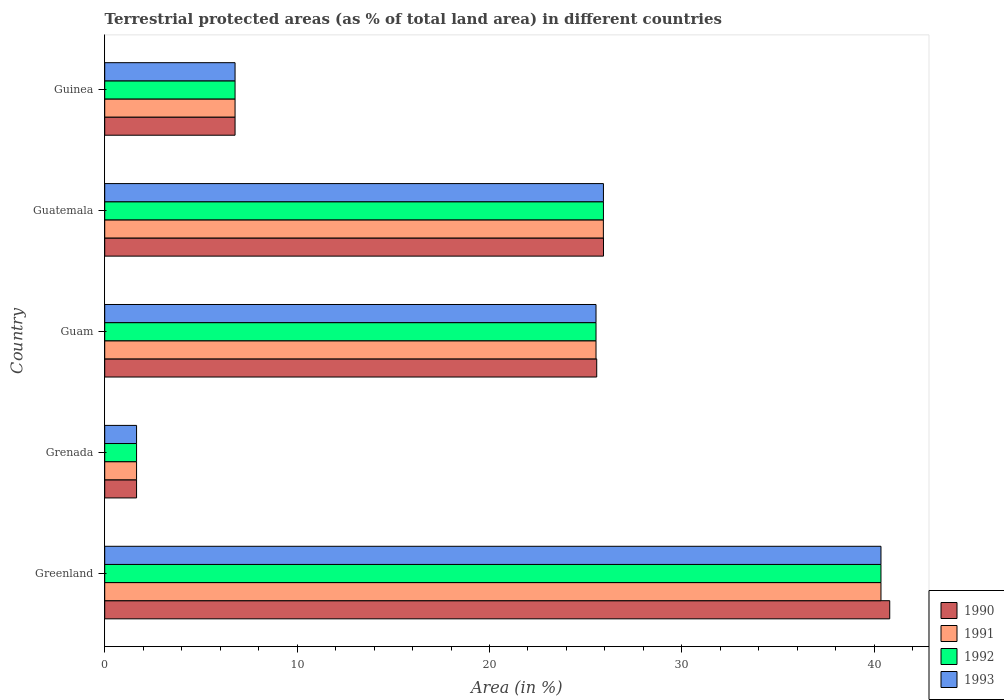How many different coloured bars are there?
Offer a very short reply. 4. How many groups of bars are there?
Provide a short and direct response. 5. Are the number of bars on each tick of the Y-axis equal?
Provide a short and direct response. Yes. How many bars are there on the 4th tick from the bottom?
Provide a short and direct response. 4. What is the label of the 4th group of bars from the top?
Give a very brief answer. Grenada. In how many cases, is the number of bars for a given country not equal to the number of legend labels?
Keep it short and to the point. 0. What is the percentage of terrestrial protected land in 1990 in Greenland?
Your answer should be compact. 40.81. Across all countries, what is the maximum percentage of terrestrial protected land in 1993?
Make the answer very short. 40.35. Across all countries, what is the minimum percentage of terrestrial protected land in 1990?
Your response must be concise. 1.66. In which country was the percentage of terrestrial protected land in 1991 maximum?
Your answer should be compact. Greenland. In which country was the percentage of terrestrial protected land in 1993 minimum?
Provide a short and direct response. Grenada. What is the total percentage of terrestrial protected land in 1990 in the graph?
Your response must be concise. 100.74. What is the difference between the percentage of terrestrial protected land in 1993 in Greenland and that in Guam?
Your response must be concise. 14.81. What is the difference between the percentage of terrestrial protected land in 1990 in Greenland and the percentage of terrestrial protected land in 1991 in Guinea?
Ensure brevity in your answer.  34.03. What is the average percentage of terrestrial protected land in 1993 per country?
Keep it short and to the point. 20.05. What is the difference between the percentage of terrestrial protected land in 1991 and percentage of terrestrial protected land in 1992 in Guam?
Your response must be concise. 0. In how many countries, is the percentage of terrestrial protected land in 1990 greater than 10 %?
Your answer should be very brief. 3. What is the ratio of the percentage of terrestrial protected land in 1992 in Greenland to that in Grenada?
Keep it short and to the point. 24.38. Is the percentage of terrestrial protected land in 1991 in Greenland less than that in Guam?
Make the answer very short. No. Is the difference between the percentage of terrestrial protected land in 1991 in Grenada and Guam greater than the difference between the percentage of terrestrial protected land in 1992 in Grenada and Guam?
Offer a very short reply. No. What is the difference between the highest and the second highest percentage of terrestrial protected land in 1991?
Provide a succinct answer. 14.43. What is the difference between the highest and the lowest percentage of terrestrial protected land in 1991?
Offer a very short reply. 38.69. In how many countries, is the percentage of terrestrial protected land in 1993 greater than the average percentage of terrestrial protected land in 1993 taken over all countries?
Your answer should be very brief. 3. Is it the case that in every country, the sum of the percentage of terrestrial protected land in 1992 and percentage of terrestrial protected land in 1990 is greater than the sum of percentage of terrestrial protected land in 1991 and percentage of terrestrial protected land in 1993?
Give a very brief answer. No. What does the 3rd bar from the top in Guam represents?
Offer a very short reply. 1991. What does the 3rd bar from the bottom in Grenada represents?
Provide a short and direct response. 1992. Are the values on the major ticks of X-axis written in scientific E-notation?
Make the answer very short. No. Does the graph contain any zero values?
Your answer should be compact. No. Does the graph contain grids?
Offer a terse response. No. How are the legend labels stacked?
Your answer should be very brief. Vertical. What is the title of the graph?
Offer a terse response. Terrestrial protected areas (as % of total land area) in different countries. Does "1986" appear as one of the legend labels in the graph?
Ensure brevity in your answer.  No. What is the label or title of the X-axis?
Make the answer very short. Area (in %). What is the Area (in %) of 1990 in Greenland?
Your answer should be compact. 40.81. What is the Area (in %) of 1991 in Greenland?
Make the answer very short. 40.35. What is the Area (in %) of 1992 in Greenland?
Your answer should be very brief. 40.35. What is the Area (in %) in 1993 in Greenland?
Offer a very short reply. 40.35. What is the Area (in %) of 1990 in Grenada?
Keep it short and to the point. 1.66. What is the Area (in %) in 1991 in Grenada?
Make the answer very short. 1.66. What is the Area (in %) of 1992 in Grenada?
Your answer should be very brief. 1.66. What is the Area (in %) of 1993 in Grenada?
Provide a short and direct response. 1.66. What is the Area (in %) in 1990 in Guam?
Make the answer very short. 25.57. What is the Area (in %) of 1991 in Guam?
Your answer should be compact. 25.54. What is the Area (in %) of 1992 in Guam?
Offer a very short reply. 25.54. What is the Area (in %) in 1993 in Guam?
Keep it short and to the point. 25.54. What is the Area (in %) of 1990 in Guatemala?
Ensure brevity in your answer.  25.93. What is the Area (in %) of 1991 in Guatemala?
Keep it short and to the point. 25.92. What is the Area (in %) in 1992 in Guatemala?
Your response must be concise. 25.92. What is the Area (in %) in 1993 in Guatemala?
Offer a terse response. 25.92. What is the Area (in %) of 1990 in Guinea?
Make the answer very short. 6.78. What is the Area (in %) of 1991 in Guinea?
Your answer should be compact. 6.78. What is the Area (in %) in 1992 in Guinea?
Your response must be concise. 6.78. What is the Area (in %) of 1993 in Guinea?
Give a very brief answer. 6.78. Across all countries, what is the maximum Area (in %) in 1990?
Your answer should be compact. 40.81. Across all countries, what is the maximum Area (in %) of 1991?
Give a very brief answer. 40.35. Across all countries, what is the maximum Area (in %) in 1992?
Your response must be concise. 40.35. Across all countries, what is the maximum Area (in %) of 1993?
Your answer should be very brief. 40.35. Across all countries, what is the minimum Area (in %) of 1990?
Your answer should be compact. 1.66. Across all countries, what is the minimum Area (in %) of 1991?
Provide a succinct answer. 1.66. Across all countries, what is the minimum Area (in %) of 1992?
Offer a terse response. 1.66. Across all countries, what is the minimum Area (in %) of 1993?
Your answer should be very brief. 1.66. What is the total Area (in %) of 1990 in the graph?
Provide a succinct answer. 100.74. What is the total Area (in %) in 1991 in the graph?
Keep it short and to the point. 100.24. What is the total Area (in %) of 1992 in the graph?
Offer a terse response. 100.24. What is the total Area (in %) in 1993 in the graph?
Offer a terse response. 100.24. What is the difference between the Area (in %) in 1990 in Greenland and that in Grenada?
Your response must be concise. 39.15. What is the difference between the Area (in %) of 1991 in Greenland and that in Grenada?
Your response must be concise. 38.69. What is the difference between the Area (in %) of 1992 in Greenland and that in Grenada?
Give a very brief answer. 38.69. What is the difference between the Area (in %) of 1993 in Greenland and that in Grenada?
Provide a succinct answer. 38.69. What is the difference between the Area (in %) of 1990 in Greenland and that in Guam?
Keep it short and to the point. 15.23. What is the difference between the Area (in %) in 1991 in Greenland and that in Guam?
Ensure brevity in your answer.  14.81. What is the difference between the Area (in %) of 1992 in Greenland and that in Guam?
Your answer should be compact. 14.81. What is the difference between the Area (in %) of 1993 in Greenland and that in Guam?
Your answer should be compact. 14.81. What is the difference between the Area (in %) in 1990 in Greenland and that in Guatemala?
Offer a very short reply. 14.88. What is the difference between the Area (in %) of 1991 in Greenland and that in Guatemala?
Keep it short and to the point. 14.43. What is the difference between the Area (in %) in 1992 in Greenland and that in Guatemala?
Make the answer very short. 14.43. What is the difference between the Area (in %) of 1993 in Greenland and that in Guatemala?
Provide a short and direct response. 14.43. What is the difference between the Area (in %) of 1990 in Greenland and that in Guinea?
Offer a terse response. 34.03. What is the difference between the Area (in %) of 1991 in Greenland and that in Guinea?
Keep it short and to the point. 33.57. What is the difference between the Area (in %) in 1992 in Greenland and that in Guinea?
Offer a very short reply. 33.57. What is the difference between the Area (in %) in 1993 in Greenland and that in Guinea?
Make the answer very short. 33.57. What is the difference between the Area (in %) in 1990 in Grenada and that in Guam?
Make the answer very short. -23.92. What is the difference between the Area (in %) in 1991 in Grenada and that in Guam?
Provide a succinct answer. -23.88. What is the difference between the Area (in %) in 1992 in Grenada and that in Guam?
Keep it short and to the point. -23.88. What is the difference between the Area (in %) in 1993 in Grenada and that in Guam?
Your answer should be very brief. -23.88. What is the difference between the Area (in %) of 1990 in Grenada and that in Guatemala?
Offer a very short reply. -24.27. What is the difference between the Area (in %) of 1991 in Grenada and that in Guatemala?
Provide a succinct answer. -24.27. What is the difference between the Area (in %) of 1992 in Grenada and that in Guatemala?
Your response must be concise. -24.27. What is the difference between the Area (in %) of 1993 in Grenada and that in Guatemala?
Make the answer very short. -24.27. What is the difference between the Area (in %) in 1990 in Grenada and that in Guinea?
Your response must be concise. -5.12. What is the difference between the Area (in %) in 1991 in Grenada and that in Guinea?
Provide a short and direct response. -5.12. What is the difference between the Area (in %) of 1992 in Grenada and that in Guinea?
Your answer should be compact. -5.12. What is the difference between the Area (in %) of 1993 in Grenada and that in Guinea?
Keep it short and to the point. -5.12. What is the difference between the Area (in %) in 1990 in Guam and that in Guatemala?
Provide a short and direct response. -0.35. What is the difference between the Area (in %) of 1991 in Guam and that in Guatemala?
Offer a terse response. -0.38. What is the difference between the Area (in %) of 1992 in Guam and that in Guatemala?
Your answer should be compact. -0.39. What is the difference between the Area (in %) in 1993 in Guam and that in Guatemala?
Give a very brief answer. -0.39. What is the difference between the Area (in %) in 1990 in Guam and that in Guinea?
Give a very brief answer. 18.8. What is the difference between the Area (in %) in 1991 in Guam and that in Guinea?
Offer a very short reply. 18.76. What is the difference between the Area (in %) in 1992 in Guam and that in Guinea?
Provide a succinct answer. 18.76. What is the difference between the Area (in %) in 1993 in Guam and that in Guinea?
Your answer should be very brief. 18.76. What is the difference between the Area (in %) in 1990 in Guatemala and that in Guinea?
Give a very brief answer. 19.15. What is the difference between the Area (in %) of 1991 in Guatemala and that in Guinea?
Your answer should be very brief. 19.15. What is the difference between the Area (in %) in 1992 in Guatemala and that in Guinea?
Give a very brief answer. 19.15. What is the difference between the Area (in %) of 1993 in Guatemala and that in Guinea?
Give a very brief answer. 19.15. What is the difference between the Area (in %) of 1990 in Greenland and the Area (in %) of 1991 in Grenada?
Provide a short and direct response. 39.15. What is the difference between the Area (in %) of 1990 in Greenland and the Area (in %) of 1992 in Grenada?
Your answer should be very brief. 39.15. What is the difference between the Area (in %) of 1990 in Greenland and the Area (in %) of 1993 in Grenada?
Your answer should be very brief. 39.15. What is the difference between the Area (in %) of 1991 in Greenland and the Area (in %) of 1992 in Grenada?
Provide a succinct answer. 38.69. What is the difference between the Area (in %) of 1991 in Greenland and the Area (in %) of 1993 in Grenada?
Provide a succinct answer. 38.69. What is the difference between the Area (in %) of 1992 in Greenland and the Area (in %) of 1993 in Grenada?
Your answer should be very brief. 38.69. What is the difference between the Area (in %) in 1990 in Greenland and the Area (in %) in 1991 in Guam?
Ensure brevity in your answer.  15.27. What is the difference between the Area (in %) in 1990 in Greenland and the Area (in %) in 1992 in Guam?
Your answer should be very brief. 15.27. What is the difference between the Area (in %) in 1990 in Greenland and the Area (in %) in 1993 in Guam?
Give a very brief answer. 15.27. What is the difference between the Area (in %) in 1991 in Greenland and the Area (in %) in 1992 in Guam?
Make the answer very short. 14.81. What is the difference between the Area (in %) of 1991 in Greenland and the Area (in %) of 1993 in Guam?
Offer a very short reply. 14.81. What is the difference between the Area (in %) in 1992 in Greenland and the Area (in %) in 1993 in Guam?
Make the answer very short. 14.81. What is the difference between the Area (in %) in 1990 in Greenland and the Area (in %) in 1991 in Guatemala?
Ensure brevity in your answer.  14.89. What is the difference between the Area (in %) of 1990 in Greenland and the Area (in %) of 1992 in Guatemala?
Your response must be concise. 14.88. What is the difference between the Area (in %) in 1990 in Greenland and the Area (in %) in 1993 in Guatemala?
Provide a succinct answer. 14.88. What is the difference between the Area (in %) of 1991 in Greenland and the Area (in %) of 1992 in Guatemala?
Your response must be concise. 14.43. What is the difference between the Area (in %) in 1991 in Greenland and the Area (in %) in 1993 in Guatemala?
Make the answer very short. 14.43. What is the difference between the Area (in %) of 1992 in Greenland and the Area (in %) of 1993 in Guatemala?
Keep it short and to the point. 14.43. What is the difference between the Area (in %) in 1990 in Greenland and the Area (in %) in 1991 in Guinea?
Your answer should be very brief. 34.03. What is the difference between the Area (in %) in 1990 in Greenland and the Area (in %) in 1992 in Guinea?
Offer a terse response. 34.03. What is the difference between the Area (in %) in 1990 in Greenland and the Area (in %) in 1993 in Guinea?
Keep it short and to the point. 34.03. What is the difference between the Area (in %) of 1991 in Greenland and the Area (in %) of 1992 in Guinea?
Your answer should be very brief. 33.57. What is the difference between the Area (in %) in 1991 in Greenland and the Area (in %) in 1993 in Guinea?
Your answer should be compact. 33.57. What is the difference between the Area (in %) in 1992 in Greenland and the Area (in %) in 1993 in Guinea?
Provide a short and direct response. 33.57. What is the difference between the Area (in %) of 1990 in Grenada and the Area (in %) of 1991 in Guam?
Offer a very short reply. -23.88. What is the difference between the Area (in %) in 1990 in Grenada and the Area (in %) in 1992 in Guam?
Your answer should be very brief. -23.88. What is the difference between the Area (in %) of 1990 in Grenada and the Area (in %) of 1993 in Guam?
Ensure brevity in your answer.  -23.88. What is the difference between the Area (in %) in 1991 in Grenada and the Area (in %) in 1992 in Guam?
Offer a very short reply. -23.88. What is the difference between the Area (in %) of 1991 in Grenada and the Area (in %) of 1993 in Guam?
Provide a short and direct response. -23.88. What is the difference between the Area (in %) of 1992 in Grenada and the Area (in %) of 1993 in Guam?
Your response must be concise. -23.88. What is the difference between the Area (in %) of 1990 in Grenada and the Area (in %) of 1991 in Guatemala?
Your answer should be compact. -24.27. What is the difference between the Area (in %) in 1990 in Grenada and the Area (in %) in 1992 in Guatemala?
Your answer should be very brief. -24.27. What is the difference between the Area (in %) in 1990 in Grenada and the Area (in %) in 1993 in Guatemala?
Provide a short and direct response. -24.27. What is the difference between the Area (in %) of 1991 in Grenada and the Area (in %) of 1992 in Guatemala?
Provide a short and direct response. -24.27. What is the difference between the Area (in %) of 1991 in Grenada and the Area (in %) of 1993 in Guatemala?
Ensure brevity in your answer.  -24.27. What is the difference between the Area (in %) of 1992 in Grenada and the Area (in %) of 1993 in Guatemala?
Your answer should be compact. -24.27. What is the difference between the Area (in %) in 1990 in Grenada and the Area (in %) in 1991 in Guinea?
Make the answer very short. -5.12. What is the difference between the Area (in %) of 1990 in Grenada and the Area (in %) of 1992 in Guinea?
Offer a very short reply. -5.12. What is the difference between the Area (in %) in 1990 in Grenada and the Area (in %) in 1993 in Guinea?
Provide a succinct answer. -5.12. What is the difference between the Area (in %) of 1991 in Grenada and the Area (in %) of 1992 in Guinea?
Ensure brevity in your answer.  -5.12. What is the difference between the Area (in %) of 1991 in Grenada and the Area (in %) of 1993 in Guinea?
Your answer should be compact. -5.12. What is the difference between the Area (in %) of 1992 in Grenada and the Area (in %) of 1993 in Guinea?
Make the answer very short. -5.12. What is the difference between the Area (in %) in 1990 in Guam and the Area (in %) in 1991 in Guatemala?
Provide a short and direct response. -0.35. What is the difference between the Area (in %) in 1990 in Guam and the Area (in %) in 1992 in Guatemala?
Offer a very short reply. -0.35. What is the difference between the Area (in %) of 1990 in Guam and the Area (in %) of 1993 in Guatemala?
Ensure brevity in your answer.  -0.35. What is the difference between the Area (in %) of 1991 in Guam and the Area (in %) of 1992 in Guatemala?
Offer a terse response. -0.39. What is the difference between the Area (in %) of 1991 in Guam and the Area (in %) of 1993 in Guatemala?
Offer a very short reply. -0.39. What is the difference between the Area (in %) of 1992 in Guam and the Area (in %) of 1993 in Guatemala?
Offer a very short reply. -0.39. What is the difference between the Area (in %) in 1990 in Guam and the Area (in %) in 1991 in Guinea?
Ensure brevity in your answer.  18.8. What is the difference between the Area (in %) of 1990 in Guam and the Area (in %) of 1992 in Guinea?
Provide a short and direct response. 18.8. What is the difference between the Area (in %) in 1990 in Guam and the Area (in %) in 1993 in Guinea?
Your response must be concise. 18.8. What is the difference between the Area (in %) of 1991 in Guam and the Area (in %) of 1992 in Guinea?
Make the answer very short. 18.76. What is the difference between the Area (in %) in 1991 in Guam and the Area (in %) in 1993 in Guinea?
Give a very brief answer. 18.76. What is the difference between the Area (in %) in 1992 in Guam and the Area (in %) in 1993 in Guinea?
Offer a terse response. 18.76. What is the difference between the Area (in %) of 1990 in Guatemala and the Area (in %) of 1991 in Guinea?
Your answer should be very brief. 19.15. What is the difference between the Area (in %) of 1990 in Guatemala and the Area (in %) of 1992 in Guinea?
Offer a very short reply. 19.15. What is the difference between the Area (in %) in 1990 in Guatemala and the Area (in %) in 1993 in Guinea?
Ensure brevity in your answer.  19.15. What is the difference between the Area (in %) in 1991 in Guatemala and the Area (in %) in 1992 in Guinea?
Give a very brief answer. 19.15. What is the difference between the Area (in %) of 1991 in Guatemala and the Area (in %) of 1993 in Guinea?
Make the answer very short. 19.15. What is the difference between the Area (in %) of 1992 in Guatemala and the Area (in %) of 1993 in Guinea?
Make the answer very short. 19.15. What is the average Area (in %) of 1990 per country?
Provide a succinct answer. 20.15. What is the average Area (in %) in 1991 per country?
Ensure brevity in your answer.  20.05. What is the average Area (in %) of 1992 per country?
Make the answer very short. 20.05. What is the average Area (in %) of 1993 per country?
Ensure brevity in your answer.  20.05. What is the difference between the Area (in %) in 1990 and Area (in %) in 1991 in Greenland?
Your answer should be compact. 0.46. What is the difference between the Area (in %) of 1990 and Area (in %) of 1992 in Greenland?
Give a very brief answer. 0.46. What is the difference between the Area (in %) of 1990 and Area (in %) of 1993 in Greenland?
Your response must be concise. 0.46. What is the difference between the Area (in %) of 1991 and Area (in %) of 1993 in Greenland?
Make the answer very short. 0. What is the difference between the Area (in %) in 1992 and Area (in %) in 1993 in Greenland?
Your answer should be compact. 0. What is the difference between the Area (in %) of 1990 and Area (in %) of 1991 in Grenada?
Make the answer very short. 0. What is the difference between the Area (in %) of 1990 and Area (in %) of 1992 in Grenada?
Ensure brevity in your answer.  0. What is the difference between the Area (in %) of 1990 and Area (in %) of 1993 in Grenada?
Provide a succinct answer. 0. What is the difference between the Area (in %) in 1991 and Area (in %) in 1992 in Grenada?
Your answer should be compact. 0. What is the difference between the Area (in %) of 1991 and Area (in %) of 1993 in Grenada?
Offer a terse response. 0. What is the difference between the Area (in %) of 1990 and Area (in %) of 1991 in Guam?
Ensure brevity in your answer.  0.04. What is the difference between the Area (in %) in 1990 and Area (in %) in 1992 in Guam?
Offer a very short reply. 0.04. What is the difference between the Area (in %) of 1990 and Area (in %) of 1993 in Guam?
Your answer should be very brief. 0.04. What is the difference between the Area (in %) in 1990 and Area (in %) in 1991 in Guatemala?
Provide a short and direct response. 0.01. What is the difference between the Area (in %) of 1990 and Area (in %) of 1992 in Guatemala?
Provide a short and direct response. 0. What is the difference between the Area (in %) in 1990 and Area (in %) in 1993 in Guatemala?
Give a very brief answer. 0. What is the difference between the Area (in %) of 1991 and Area (in %) of 1992 in Guatemala?
Give a very brief answer. -0. What is the difference between the Area (in %) of 1991 and Area (in %) of 1993 in Guatemala?
Ensure brevity in your answer.  -0. What is the difference between the Area (in %) of 1992 and Area (in %) of 1993 in Guatemala?
Your answer should be very brief. 0. What is the difference between the Area (in %) of 1990 and Area (in %) of 1991 in Guinea?
Ensure brevity in your answer.  0. What is the difference between the Area (in %) of 1990 and Area (in %) of 1993 in Guinea?
Offer a terse response. 0. What is the difference between the Area (in %) in 1991 and Area (in %) in 1993 in Guinea?
Provide a short and direct response. 0. What is the difference between the Area (in %) in 1992 and Area (in %) in 1993 in Guinea?
Give a very brief answer. 0. What is the ratio of the Area (in %) of 1990 in Greenland to that in Grenada?
Your answer should be very brief. 24.65. What is the ratio of the Area (in %) in 1991 in Greenland to that in Grenada?
Your answer should be very brief. 24.38. What is the ratio of the Area (in %) of 1992 in Greenland to that in Grenada?
Make the answer very short. 24.38. What is the ratio of the Area (in %) of 1993 in Greenland to that in Grenada?
Provide a short and direct response. 24.38. What is the ratio of the Area (in %) of 1990 in Greenland to that in Guam?
Give a very brief answer. 1.6. What is the ratio of the Area (in %) in 1991 in Greenland to that in Guam?
Your response must be concise. 1.58. What is the ratio of the Area (in %) in 1992 in Greenland to that in Guam?
Your response must be concise. 1.58. What is the ratio of the Area (in %) in 1993 in Greenland to that in Guam?
Your response must be concise. 1.58. What is the ratio of the Area (in %) in 1990 in Greenland to that in Guatemala?
Ensure brevity in your answer.  1.57. What is the ratio of the Area (in %) of 1991 in Greenland to that in Guatemala?
Give a very brief answer. 1.56. What is the ratio of the Area (in %) of 1992 in Greenland to that in Guatemala?
Ensure brevity in your answer.  1.56. What is the ratio of the Area (in %) of 1993 in Greenland to that in Guatemala?
Provide a short and direct response. 1.56. What is the ratio of the Area (in %) of 1990 in Greenland to that in Guinea?
Your response must be concise. 6.02. What is the ratio of the Area (in %) of 1991 in Greenland to that in Guinea?
Give a very brief answer. 5.96. What is the ratio of the Area (in %) of 1992 in Greenland to that in Guinea?
Offer a very short reply. 5.96. What is the ratio of the Area (in %) in 1993 in Greenland to that in Guinea?
Provide a short and direct response. 5.96. What is the ratio of the Area (in %) in 1990 in Grenada to that in Guam?
Ensure brevity in your answer.  0.06. What is the ratio of the Area (in %) in 1991 in Grenada to that in Guam?
Your answer should be very brief. 0.06. What is the ratio of the Area (in %) in 1992 in Grenada to that in Guam?
Keep it short and to the point. 0.06. What is the ratio of the Area (in %) in 1993 in Grenada to that in Guam?
Offer a terse response. 0.06. What is the ratio of the Area (in %) in 1990 in Grenada to that in Guatemala?
Give a very brief answer. 0.06. What is the ratio of the Area (in %) of 1991 in Grenada to that in Guatemala?
Give a very brief answer. 0.06. What is the ratio of the Area (in %) in 1992 in Grenada to that in Guatemala?
Your answer should be very brief. 0.06. What is the ratio of the Area (in %) in 1993 in Grenada to that in Guatemala?
Your response must be concise. 0.06. What is the ratio of the Area (in %) of 1990 in Grenada to that in Guinea?
Keep it short and to the point. 0.24. What is the ratio of the Area (in %) in 1991 in Grenada to that in Guinea?
Keep it short and to the point. 0.24. What is the ratio of the Area (in %) in 1992 in Grenada to that in Guinea?
Provide a short and direct response. 0.24. What is the ratio of the Area (in %) in 1993 in Grenada to that in Guinea?
Make the answer very short. 0.24. What is the ratio of the Area (in %) in 1990 in Guam to that in Guatemala?
Keep it short and to the point. 0.99. What is the ratio of the Area (in %) in 1991 in Guam to that in Guatemala?
Provide a succinct answer. 0.99. What is the ratio of the Area (in %) in 1992 in Guam to that in Guatemala?
Offer a very short reply. 0.99. What is the ratio of the Area (in %) of 1993 in Guam to that in Guatemala?
Offer a very short reply. 0.99. What is the ratio of the Area (in %) of 1990 in Guam to that in Guinea?
Offer a very short reply. 3.77. What is the ratio of the Area (in %) in 1991 in Guam to that in Guinea?
Ensure brevity in your answer.  3.77. What is the ratio of the Area (in %) of 1992 in Guam to that in Guinea?
Provide a short and direct response. 3.77. What is the ratio of the Area (in %) of 1993 in Guam to that in Guinea?
Your answer should be very brief. 3.77. What is the ratio of the Area (in %) of 1990 in Guatemala to that in Guinea?
Your response must be concise. 3.83. What is the ratio of the Area (in %) of 1991 in Guatemala to that in Guinea?
Offer a very short reply. 3.83. What is the ratio of the Area (in %) of 1992 in Guatemala to that in Guinea?
Make the answer very short. 3.83. What is the ratio of the Area (in %) in 1993 in Guatemala to that in Guinea?
Your response must be concise. 3.83. What is the difference between the highest and the second highest Area (in %) of 1990?
Your answer should be very brief. 14.88. What is the difference between the highest and the second highest Area (in %) in 1991?
Provide a short and direct response. 14.43. What is the difference between the highest and the second highest Area (in %) of 1992?
Give a very brief answer. 14.43. What is the difference between the highest and the second highest Area (in %) in 1993?
Your response must be concise. 14.43. What is the difference between the highest and the lowest Area (in %) in 1990?
Offer a terse response. 39.15. What is the difference between the highest and the lowest Area (in %) of 1991?
Give a very brief answer. 38.69. What is the difference between the highest and the lowest Area (in %) in 1992?
Your response must be concise. 38.69. What is the difference between the highest and the lowest Area (in %) in 1993?
Offer a very short reply. 38.69. 